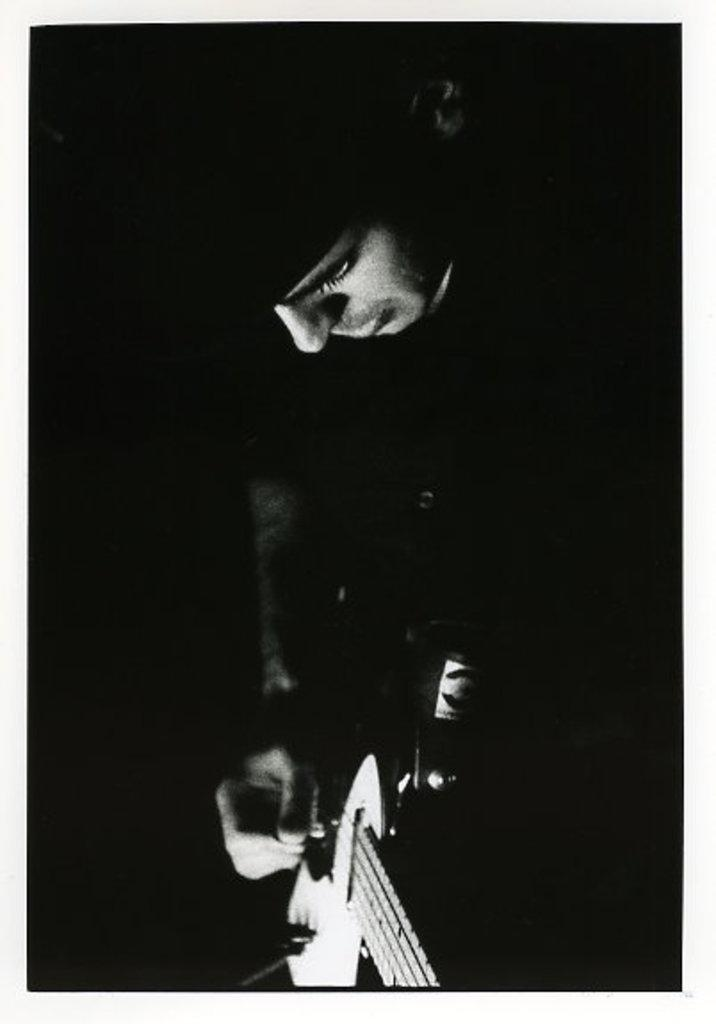What is the main subject of the image? There is a person in the image. What is the person doing in the image? The person is playing a guitar. Where is the cannon located in the image? There is no cannon present in the image. What type of throne is the person sitting on while playing the guitar? There is no throne present in the image; the person is standing while playing the guitar. 